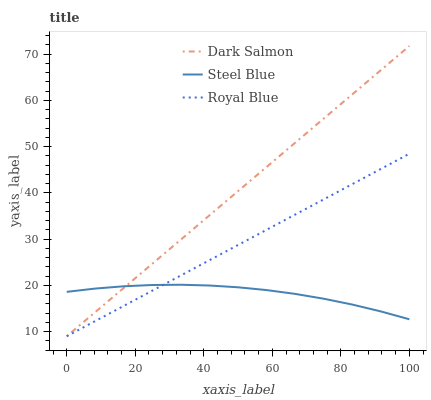Does Steel Blue have the minimum area under the curve?
Answer yes or no. Yes. Does Dark Salmon have the maximum area under the curve?
Answer yes or no. Yes. Does Dark Salmon have the minimum area under the curve?
Answer yes or no. No. Does Steel Blue have the maximum area under the curve?
Answer yes or no. No. Is Royal Blue the smoothest?
Answer yes or no. Yes. Is Steel Blue the roughest?
Answer yes or no. Yes. Is Dark Salmon the smoothest?
Answer yes or no. No. Is Dark Salmon the roughest?
Answer yes or no. No. Does Royal Blue have the lowest value?
Answer yes or no. Yes. Does Steel Blue have the lowest value?
Answer yes or no. No. Does Dark Salmon have the highest value?
Answer yes or no. Yes. Does Steel Blue have the highest value?
Answer yes or no. No. Does Royal Blue intersect Dark Salmon?
Answer yes or no. Yes. Is Royal Blue less than Dark Salmon?
Answer yes or no. No. Is Royal Blue greater than Dark Salmon?
Answer yes or no. No. 